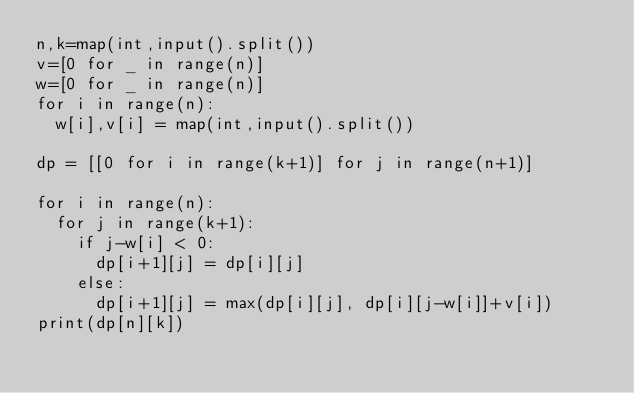<code> <loc_0><loc_0><loc_500><loc_500><_Python_>n,k=map(int,input().split())
v=[0 for _ in range(n)]
w=[0 for _ in range(n)]
for i in range(n):
	w[i],v[i] = map(int,input().split())
 
dp = [[0 for i in range(k+1)] for j in range(n+1)]
 
for i in range(n):
	for j in range(k+1):
		if j-w[i] < 0:
			dp[i+1][j] = dp[i][j]
		else:
			dp[i+1][j] = max(dp[i][j], dp[i][j-w[i]]+v[i])
print(dp[n][k])</code> 